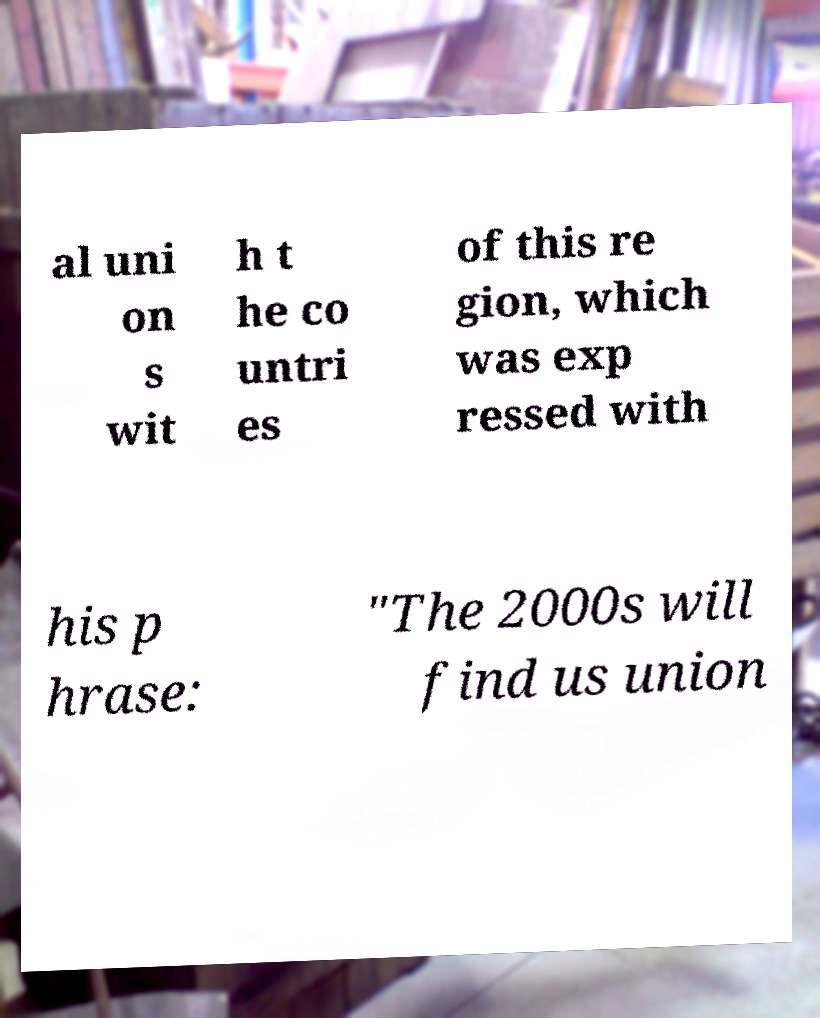Could you extract and type out the text from this image? al uni on s wit h t he co untri es of this re gion, which was exp ressed with his p hrase: "The 2000s will find us union 